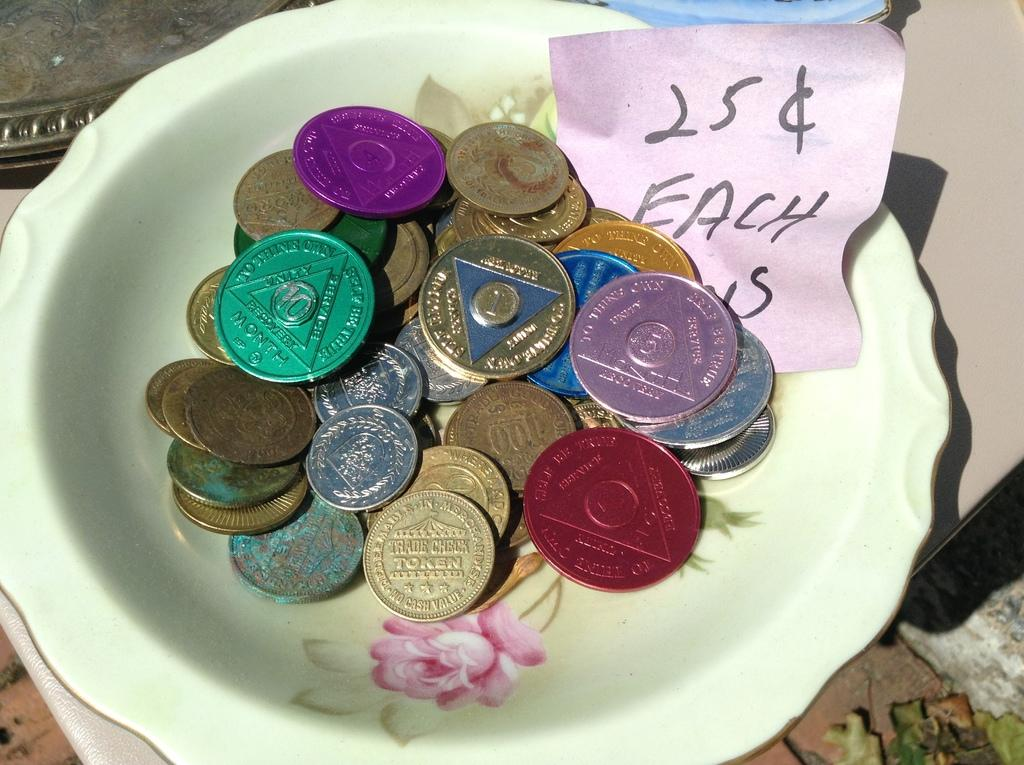<image>
Render a clear and concise summary of the photo. a bowl of coins that are on sale for 25 cents each 